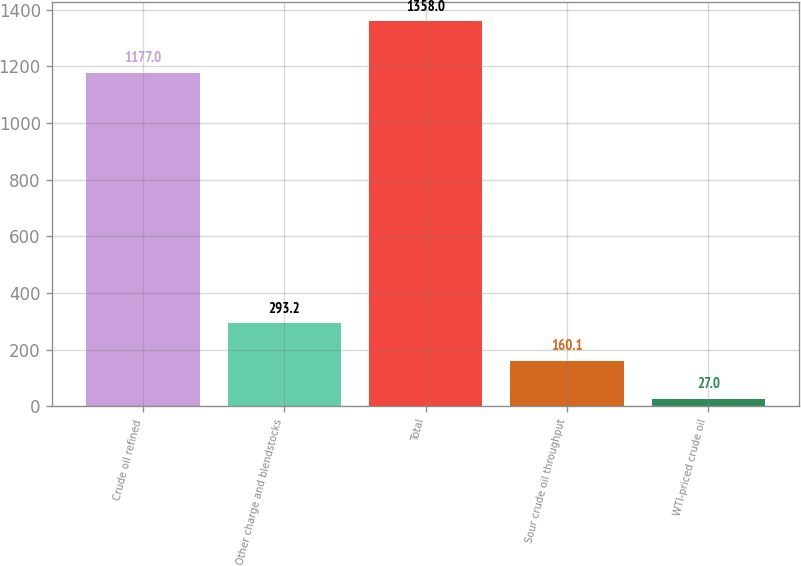Convert chart to OTSL. <chart><loc_0><loc_0><loc_500><loc_500><bar_chart><fcel>Crude oil refined<fcel>Other charge and blendstocks<fcel>Total<fcel>Sour crude oil throughput<fcel>WTI-priced crude oil<nl><fcel>1177<fcel>293.2<fcel>1358<fcel>160.1<fcel>27<nl></chart> 